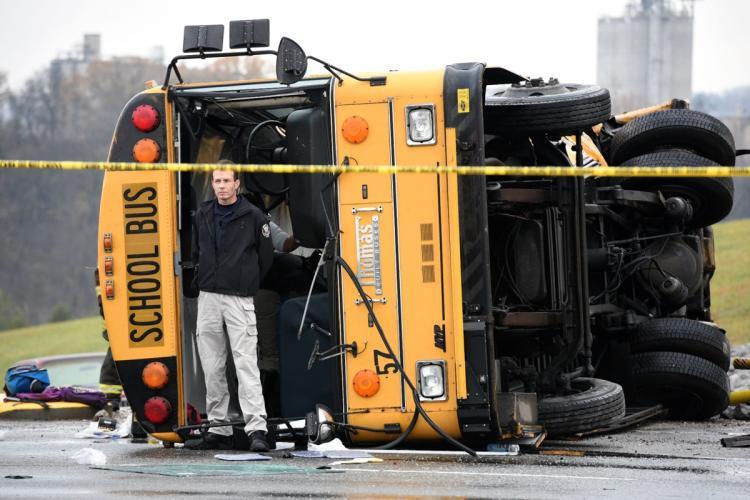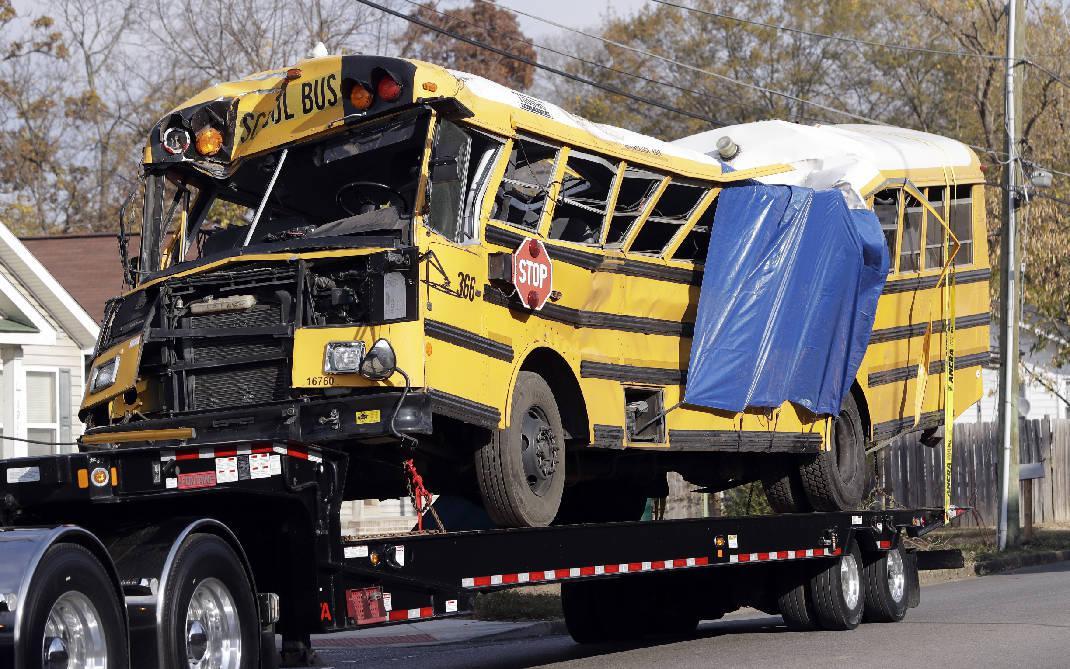The first image is the image on the left, the second image is the image on the right. For the images displayed, is the sentence "A blue tarp covers the side of the bus in one of the images." factually correct? Answer yes or no. Yes. The first image is the image on the left, the second image is the image on the right. Evaluate the accuracy of this statement regarding the images: "there is a bus on the back of a flat bed tow truck". Is it true? Answer yes or no. Yes. 